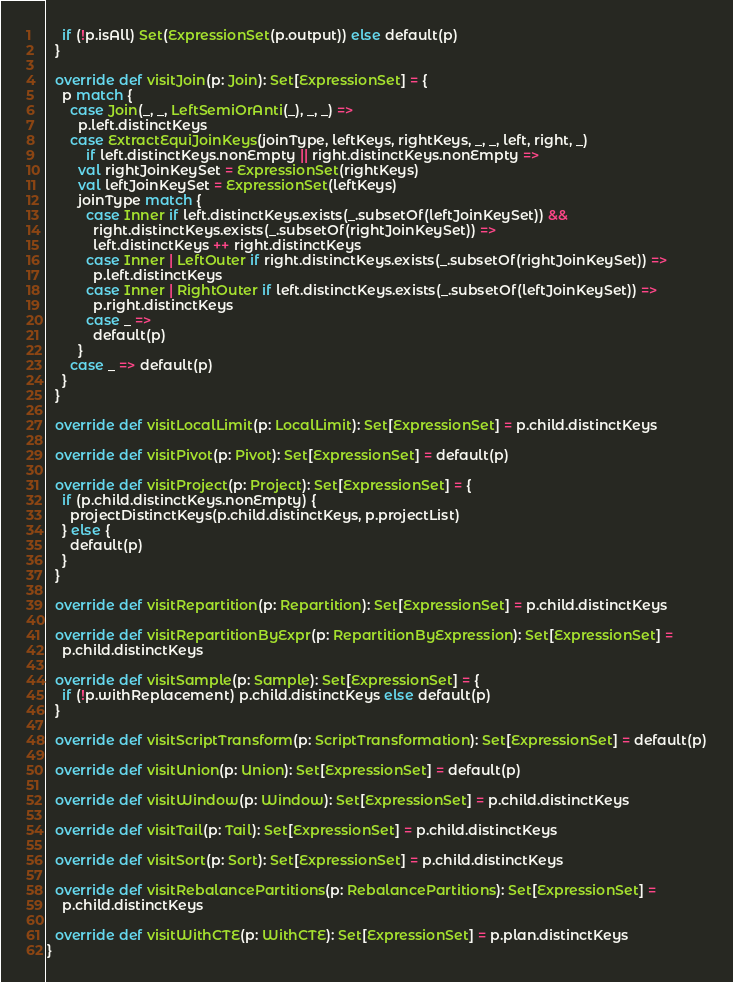Convert code to text. <code><loc_0><loc_0><loc_500><loc_500><_Scala_>    if (!p.isAll) Set(ExpressionSet(p.output)) else default(p)
  }

  override def visitJoin(p: Join): Set[ExpressionSet] = {
    p match {
      case Join(_, _, LeftSemiOrAnti(_), _, _) =>
        p.left.distinctKeys
      case ExtractEquiJoinKeys(joinType, leftKeys, rightKeys, _, _, left, right, _)
          if left.distinctKeys.nonEmpty || right.distinctKeys.nonEmpty =>
        val rightJoinKeySet = ExpressionSet(rightKeys)
        val leftJoinKeySet = ExpressionSet(leftKeys)
        joinType match {
          case Inner if left.distinctKeys.exists(_.subsetOf(leftJoinKeySet)) &&
            right.distinctKeys.exists(_.subsetOf(rightJoinKeySet)) =>
            left.distinctKeys ++ right.distinctKeys
          case Inner | LeftOuter if right.distinctKeys.exists(_.subsetOf(rightJoinKeySet)) =>
            p.left.distinctKeys
          case Inner | RightOuter if left.distinctKeys.exists(_.subsetOf(leftJoinKeySet)) =>
            p.right.distinctKeys
          case _ =>
            default(p)
        }
      case _ => default(p)
    }
  }

  override def visitLocalLimit(p: LocalLimit): Set[ExpressionSet] = p.child.distinctKeys

  override def visitPivot(p: Pivot): Set[ExpressionSet] = default(p)

  override def visitProject(p: Project): Set[ExpressionSet] = {
    if (p.child.distinctKeys.nonEmpty) {
      projectDistinctKeys(p.child.distinctKeys, p.projectList)
    } else {
      default(p)
    }
  }

  override def visitRepartition(p: Repartition): Set[ExpressionSet] = p.child.distinctKeys

  override def visitRepartitionByExpr(p: RepartitionByExpression): Set[ExpressionSet] =
    p.child.distinctKeys

  override def visitSample(p: Sample): Set[ExpressionSet] = {
    if (!p.withReplacement) p.child.distinctKeys else default(p)
  }

  override def visitScriptTransform(p: ScriptTransformation): Set[ExpressionSet] = default(p)

  override def visitUnion(p: Union): Set[ExpressionSet] = default(p)

  override def visitWindow(p: Window): Set[ExpressionSet] = p.child.distinctKeys

  override def visitTail(p: Tail): Set[ExpressionSet] = p.child.distinctKeys

  override def visitSort(p: Sort): Set[ExpressionSet] = p.child.distinctKeys

  override def visitRebalancePartitions(p: RebalancePartitions): Set[ExpressionSet] =
    p.child.distinctKeys

  override def visitWithCTE(p: WithCTE): Set[ExpressionSet] = p.plan.distinctKeys
}
</code> 